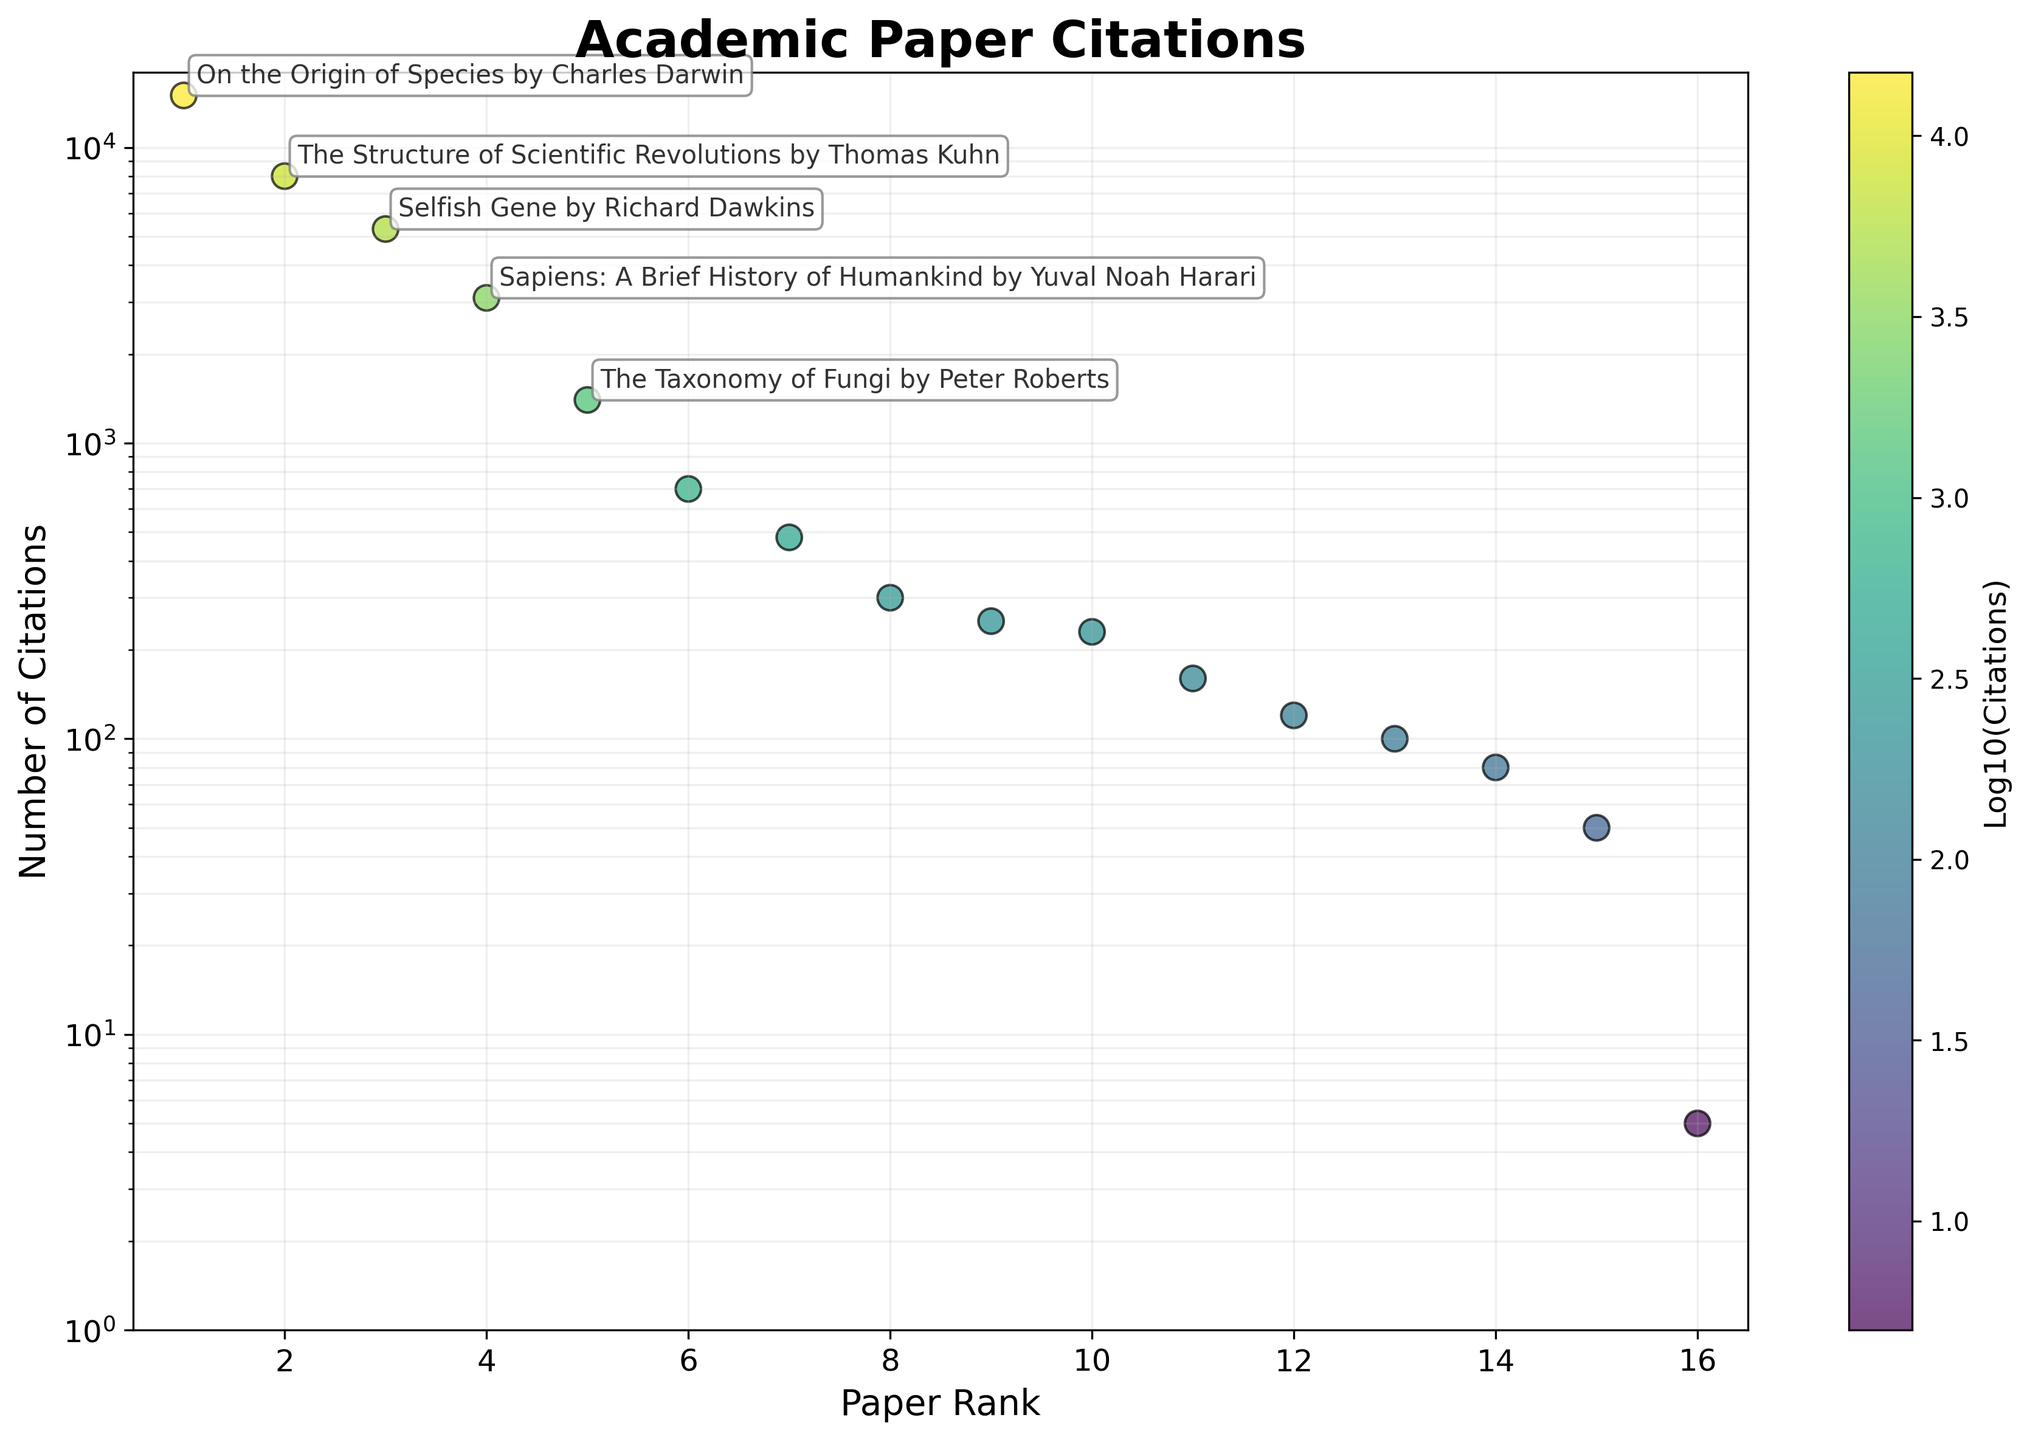How many papers have less than 100 citations? To find the number of papers with less than 100 citations, look for the points on the scatter plot that are below the horizontal line at 100 citations on the log scale axis. Identifying these points indicates how many papers fall below this threshold.
Answer: 3 What is the title of the paper with the highest number of citations? Refer to the annotated data points on the scatter plot where the top 5 papers are marked. The first point, which has the highest value on the y-axis, will indicate the paper with the most citations.
Answer: "On the Origin of Species by Charles Darwin" What is the total number of citations for the three least cited papers? Identify the three lowest data points on the scatter plot by checking the y-axis values. These papers are annotated in the least positions. Sum their citations: Thoreau's Axe (5), A Field Guide to Lichens (50), and Discovering Lichen Diversity (80). Total: 5 + 50 + 80.
Answer: 135 Which paper has more citations: "The Taxonomy of Fungi by Peter Roberts" or "The Hidden Life of Trees by Peter Wohlleben"? Locate the annotation and the corresponding points for both papers on the scatter plot. Compare their vertical positions (y-axis values). "The Taxonomy of Fungi by Peter Roberts" has 1400 citations, while "The Hidden Life of Trees by Peter Wohlleben" has 700 citations.
Answer: "The Taxonomy of Fungi by Peter Roberts" What is the approximate range of citations for the papers shown in the plot? The range is found by subtracting the lowest citation count from the highest citation count on the plot. The highest citation is for "On the Origin of Species by Charles Darwin" (15000) and the lowest is "Thoreau's Axe" (5). Subtract 5 from 15000.
Answer: 14995 Which paper ranks 4th in terms of citations, and how many citations does it have? Look at the order of annotated points starting from the highest to the fourth point. The 4th annotated point is "Sapiens: A Brief History of Humankind by Yuval Noah Harari" with the corresponding y-axis value for citations.
Answer: "Sapiens: A Brief History of Humankind by Yuval Noah Harari", 3100 What is the median number of citations for all the papers? To find the median, sort all citation counts and find the middle value. With 15 papers, the median is the 8th data point in the sorted list. Locate this point in the plot: the sorted citations from lowest to highest would place "Lichens of North America by I.M. Brodo" at the middle (160 citations).
Answer: 160 How many papers have a logarithmic value of citations greater than 3? Convert the logarithmic value to citation counts. The logarithmic value of 3 corresponds to 10^3 = 1000 citations. Count the number of papers above this threshold on the plot, which are visually higher than this value on the y-axis.
Answer: 4 